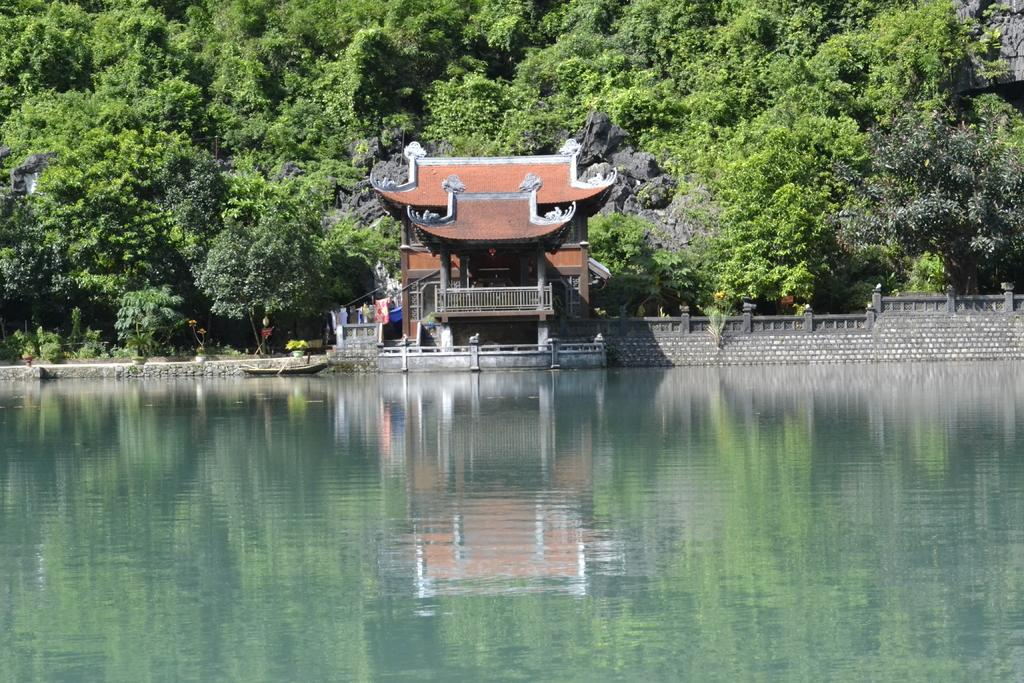What type of natural body of water is present in the image? There is a lake in the image. What type of structure is visible in the image? There is a house in the image. Which part of the house is visible in the image? The back of the house is visible in the image. What type of vegetation is present in the image? There are trees in the image. What type of afternoon activity is taking place in the image? There is no specific afternoon activity depicted in the image; it simply shows a lake, a house, and trees. What type of attraction is present in the image? There is no specific attraction present in the image; it simply shows a lake, a house, and trees. 